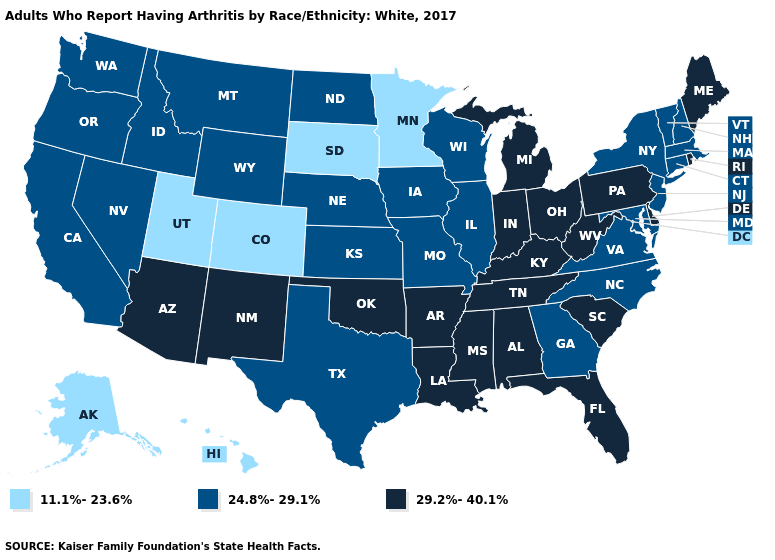Name the states that have a value in the range 29.2%-40.1%?
Be succinct. Alabama, Arizona, Arkansas, Delaware, Florida, Indiana, Kentucky, Louisiana, Maine, Michigan, Mississippi, New Mexico, Ohio, Oklahoma, Pennsylvania, Rhode Island, South Carolina, Tennessee, West Virginia. Name the states that have a value in the range 11.1%-23.6%?
Short answer required. Alaska, Colorado, Hawaii, Minnesota, South Dakota, Utah. Name the states that have a value in the range 11.1%-23.6%?
Keep it brief. Alaska, Colorado, Hawaii, Minnesota, South Dakota, Utah. What is the highest value in the Northeast ?
Give a very brief answer. 29.2%-40.1%. What is the lowest value in states that border Texas?
Be succinct. 29.2%-40.1%. Name the states that have a value in the range 11.1%-23.6%?
Keep it brief. Alaska, Colorado, Hawaii, Minnesota, South Dakota, Utah. Name the states that have a value in the range 29.2%-40.1%?
Quick response, please. Alabama, Arizona, Arkansas, Delaware, Florida, Indiana, Kentucky, Louisiana, Maine, Michigan, Mississippi, New Mexico, Ohio, Oklahoma, Pennsylvania, Rhode Island, South Carolina, Tennessee, West Virginia. What is the value of Oregon?
Be succinct. 24.8%-29.1%. Which states have the lowest value in the South?
Answer briefly. Georgia, Maryland, North Carolina, Texas, Virginia. Which states have the lowest value in the MidWest?
Quick response, please. Minnesota, South Dakota. Which states hav the highest value in the MidWest?
Write a very short answer. Indiana, Michigan, Ohio. What is the value of Alaska?
Write a very short answer. 11.1%-23.6%. What is the lowest value in the USA?
Concise answer only. 11.1%-23.6%. Which states have the highest value in the USA?
Keep it brief. Alabama, Arizona, Arkansas, Delaware, Florida, Indiana, Kentucky, Louisiana, Maine, Michigan, Mississippi, New Mexico, Ohio, Oklahoma, Pennsylvania, Rhode Island, South Carolina, Tennessee, West Virginia. What is the value of Vermont?
Write a very short answer. 24.8%-29.1%. 